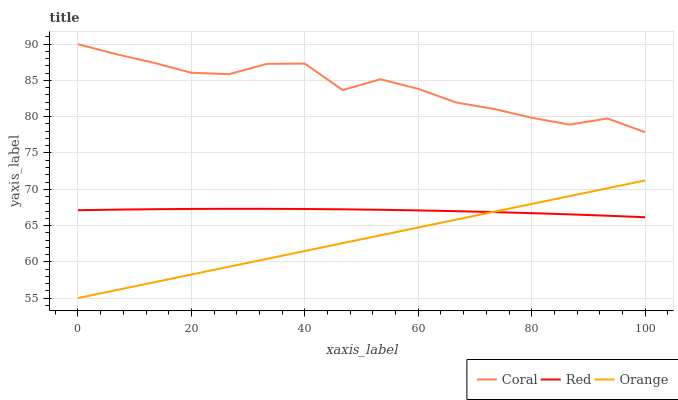Does Orange have the minimum area under the curve?
Answer yes or no. Yes. Does Coral have the maximum area under the curve?
Answer yes or no. Yes. Does Red have the minimum area under the curve?
Answer yes or no. No. Does Red have the maximum area under the curve?
Answer yes or no. No. Is Orange the smoothest?
Answer yes or no. Yes. Is Coral the roughest?
Answer yes or no. Yes. Is Red the smoothest?
Answer yes or no. No. Is Red the roughest?
Answer yes or no. No. Does Orange have the lowest value?
Answer yes or no. Yes. Does Red have the lowest value?
Answer yes or no. No. Does Coral have the highest value?
Answer yes or no. Yes. Does Red have the highest value?
Answer yes or no. No. Is Red less than Coral?
Answer yes or no. Yes. Is Coral greater than Red?
Answer yes or no. Yes. Does Red intersect Orange?
Answer yes or no. Yes. Is Red less than Orange?
Answer yes or no. No. Is Red greater than Orange?
Answer yes or no. No. Does Red intersect Coral?
Answer yes or no. No. 